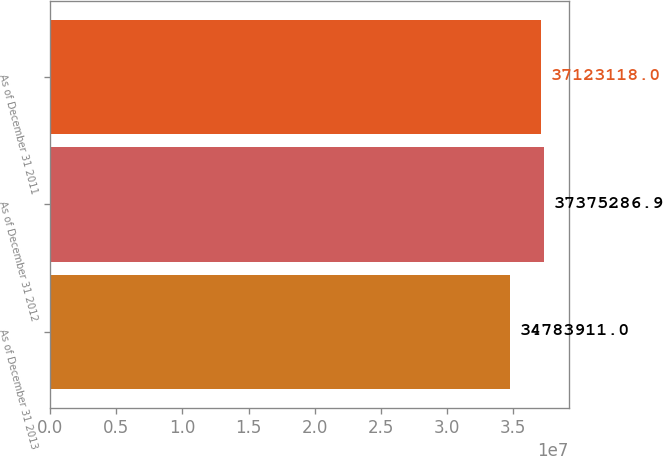<chart> <loc_0><loc_0><loc_500><loc_500><bar_chart><fcel>As of December 31 2013<fcel>As of December 31 2012<fcel>As of December 31 2011<nl><fcel>3.47839e+07<fcel>3.73753e+07<fcel>3.71231e+07<nl></chart> 